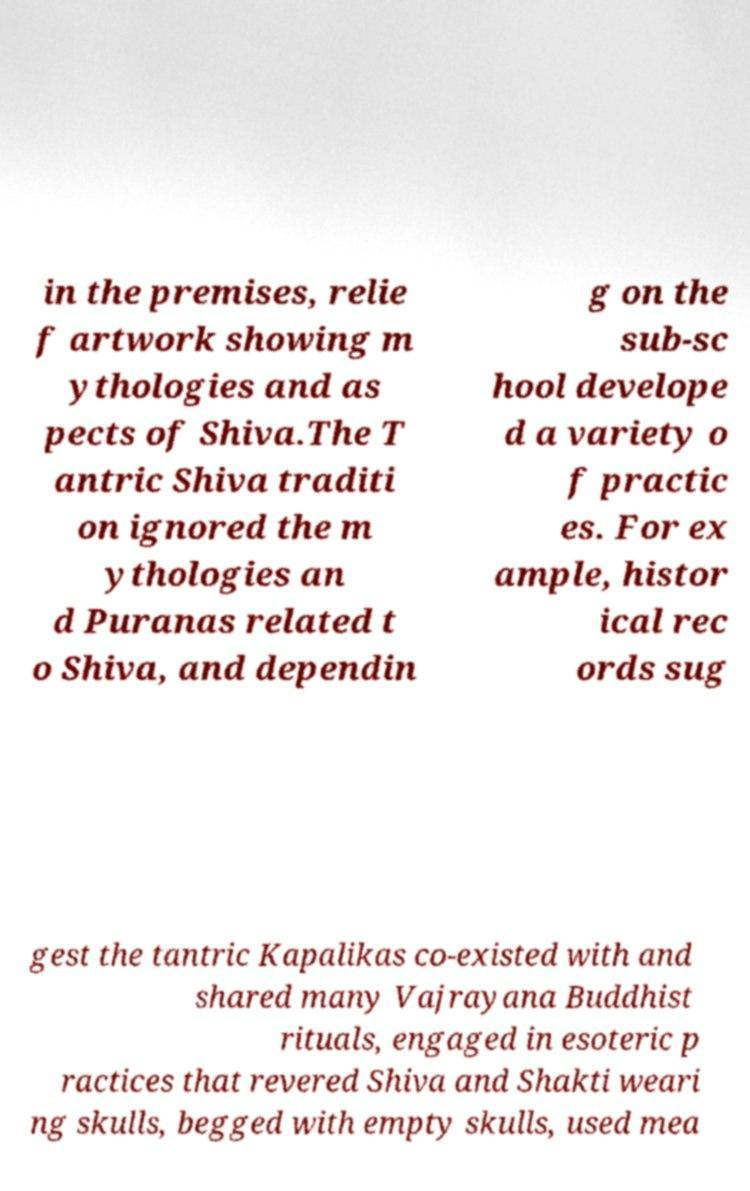For documentation purposes, I need the text within this image transcribed. Could you provide that? in the premises, relie f artwork showing m ythologies and as pects of Shiva.The T antric Shiva traditi on ignored the m ythologies an d Puranas related t o Shiva, and dependin g on the sub-sc hool develope d a variety o f practic es. For ex ample, histor ical rec ords sug gest the tantric Kapalikas co-existed with and shared many Vajrayana Buddhist rituals, engaged in esoteric p ractices that revered Shiva and Shakti weari ng skulls, begged with empty skulls, used mea 